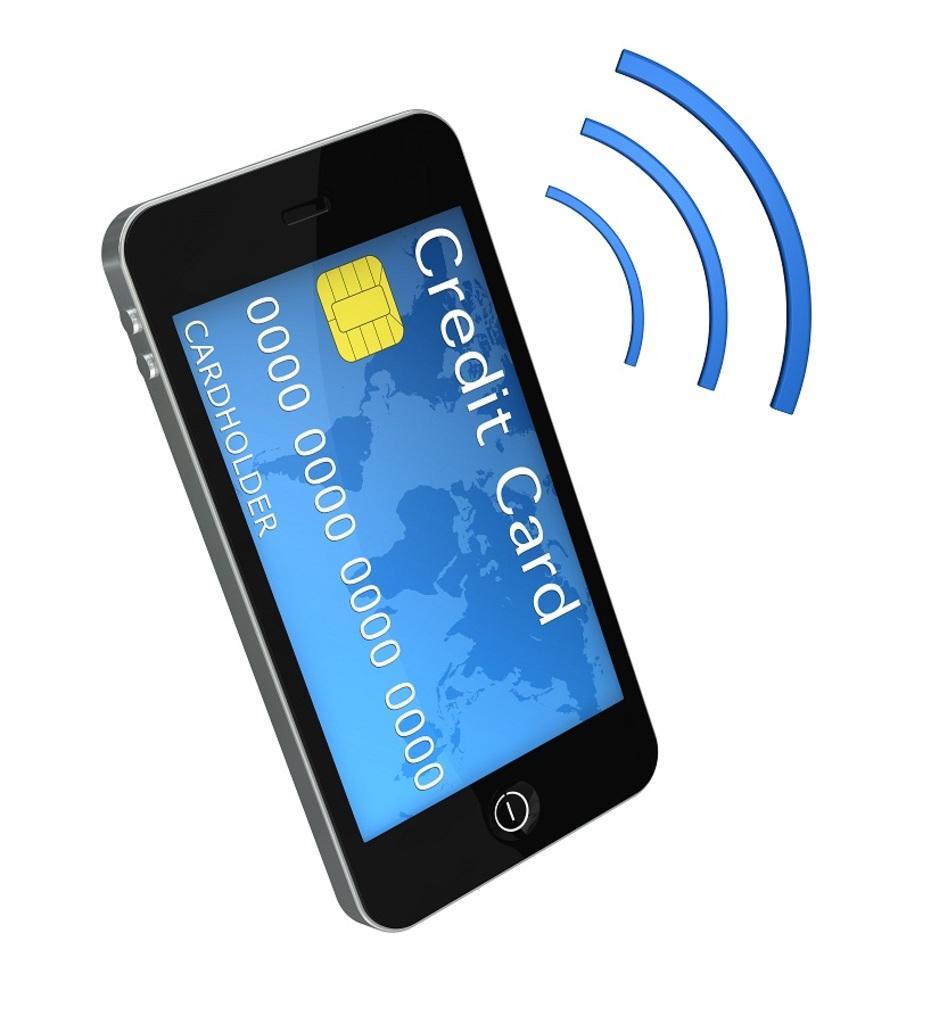How would you summarize this image in a sentence or two? On the left side, there is a mobile having a screen. On the right side, there are three blue color curved lines. And the background of this image is white in color. 